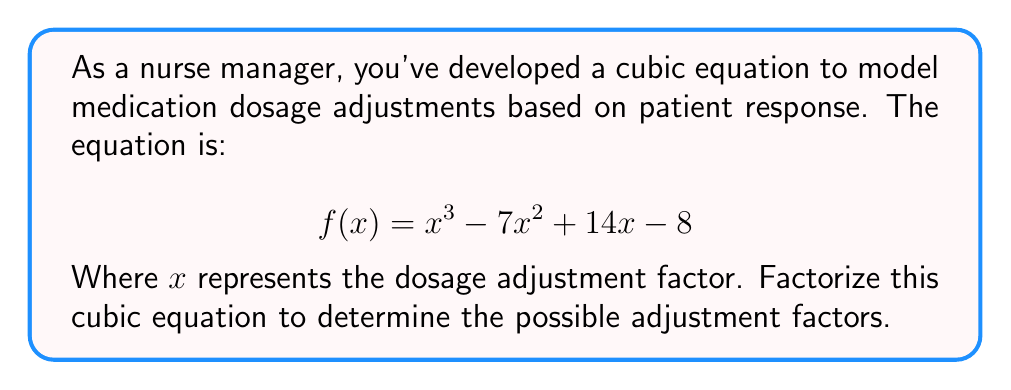Teach me how to tackle this problem. To factorize this cubic equation, we'll follow these steps:

1) First, let's check if there's a rational root. We can use the rational root theorem to list possible roots: ±1, ±2, ±4, ±8.

2) By testing these values, we find that $f(1) = 0$. So $(x-1)$ is a factor.

3) We can use polynomial long division to divide $f(x)$ by $(x-1)$:

   $$\frac{x^3 - 7x^2 + 14x - 8}{x-1} = x^2 - 6x + 8$$

4) Now we have: $f(x) = (x-1)(x^2 - 6x + 8)$

5) We need to factorize the quadratic term $x^2 - 6x + 8$:
   - The sum of roots is 6
   - The product of roots is 8
   - The roots are 2 and 4

6) Therefore, $x^2 - 6x + 8 = (x-2)(x-4)$

7) Combining all factors, we get:

   $$f(x) = (x-1)(x-2)(x-4)$$

This factorization shows that the possible dosage adjustment factors are 1, 2, and 4.
Answer: $(x-1)(x-2)(x-4)$ 